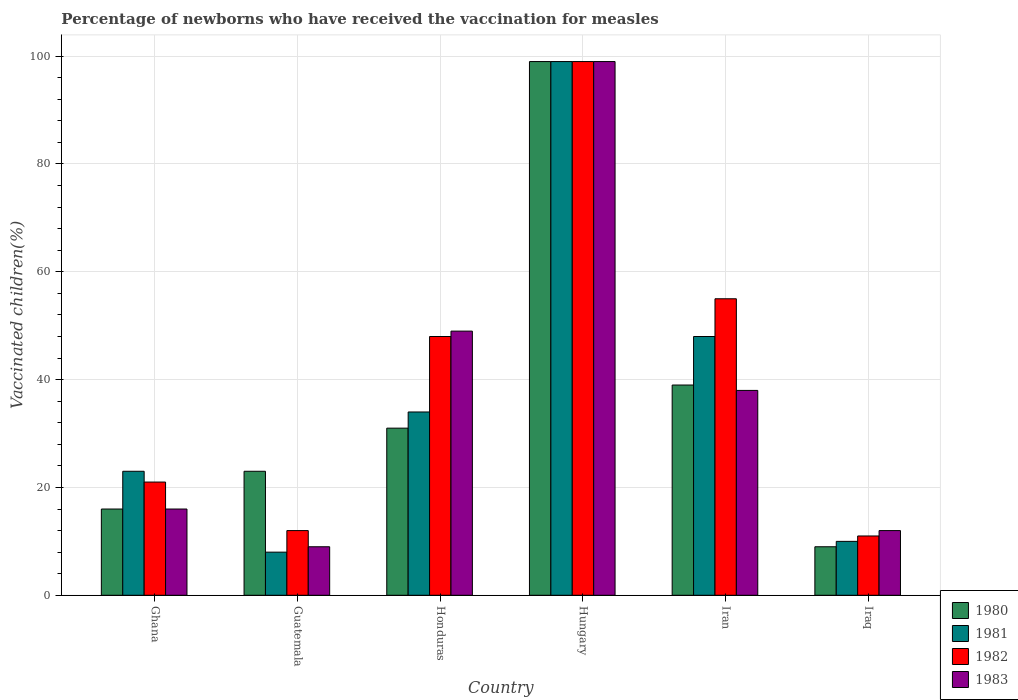How many different coloured bars are there?
Give a very brief answer. 4. Are the number of bars on each tick of the X-axis equal?
Provide a succinct answer. Yes. How many bars are there on the 5th tick from the right?
Make the answer very short. 4. What is the label of the 1st group of bars from the left?
Your answer should be very brief. Ghana. In how many cases, is the number of bars for a given country not equal to the number of legend labels?
Offer a very short reply. 0. Across all countries, what is the maximum percentage of vaccinated children in 1981?
Make the answer very short. 99. In which country was the percentage of vaccinated children in 1980 maximum?
Provide a succinct answer. Hungary. In which country was the percentage of vaccinated children in 1982 minimum?
Keep it short and to the point. Iraq. What is the total percentage of vaccinated children in 1982 in the graph?
Keep it short and to the point. 246. What is the difference between the percentage of vaccinated children in 1981 in Hungary and the percentage of vaccinated children in 1983 in Iran?
Offer a terse response. 61. What is the average percentage of vaccinated children in 1983 per country?
Give a very brief answer. 37.17. What is the ratio of the percentage of vaccinated children in 1980 in Ghana to that in Guatemala?
Keep it short and to the point. 0.7. What is the difference between the highest and the second highest percentage of vaccinated children in 1982?
Your answer should be compact. -51. What is the difference between the highest and the lowest percentage of vaccinated children in 1981?
Provide a succinct answer. 91. Is the sum of the percentage of vaccinated children in 1980 in Guatemala and Honduras greater than the maximum percentage of vaccinated children in 1982 across all countries?
Provide a short and direct response. No. Is it the case that in every country, the sum of the percentage of vaccinated children in 1983 and percentage of vaccinated children in 1980 is greater than the sum of percentage of vaccinated children in 1981 and percentage of vaccinated children in 1982?
Give a very brief answer. No. Are all the bars in the graph horizontal?
Make the answer very short. No. Does the graph contain any zero values?
Your response must be concise. No. Does the graph contain grids?
Offer a very short reply. Yes. How are the legend labels stacked?
Keep it short and to the point. Vertical. What is the title of the graph?
Keep it short and to the point. Percentage of newborns who have received the vaccination for measles. Does "1969" appear as one of the legend labels in the graph?
Offer a terse response. No. What is the label or title of the Y-axis?
Make the answer very short. Vaccinated children(%). What is the Vaccinated children(%) in 1980 in Ghana?
Make the answer very short. 16. What is the Vaccinated children(%) of 1983 in Ghana?
Offer a terse response. 16. What is the Vaccinated children(%) in 1981 in Guatemala?
Ensure brevity in your answer.  8. What is the Vaccinated children(%) in 1983 in Guatemala?
Provide a short and direct response. 9. What is the Vaccinated children(%) of 1980 in Honduras?
Your answer should be very brief. 31. What is the Vaccinated children(%) in 1982 in Honduras?
Offer a terse response. 48. What is the Vaccinated children(%) in 1980 in Hungary?
Ensure brevity in your answer.  99. What is the Vaccinated children(%) in 1981 in Hungary?
Ensure brevity in your answer.  99. What is the Vaccinated children(%) in 1982 in Hungary?
Offer a very short reply. 99. What is the Vaccinated children(%) of 1980 in Iran?
Give a very brief answer. 39. What is the Vaccinated children(%) of 1981 in Iran?
Provide a succinct answer. 48. What is the Vaccinated children(%) of 1980 in Iraq?
Your response must be concise. 9. Across all countries, what is the maximum Vaccinated children(%) of 1980?
Your answer should be compact. 99. Across all countries, what is the maximum Vaccinated children(%) of 1981?
Give a very brief answer. 99. Across all countries, what is the maximum Vaccinated children(%) of 1983?
Make the answer very short. 99. Across all countries, what is the minimum Vaccinated children(%) of 1981?
Make the answer very short. 8. Across all countries, what is the minimum Vaccinated children(%) in 1983?
Offer a very short reply. 9. What is the total Vaccinated children(%) in 1980 in the graph?
Provide a succinct answer. 217. What is the total Vaccinated children(%) in 1981 in the graph?
Your response must be concise. 222. What is the total Vaccinated children(%) in 1982 in the graph?
Ensure brevity in your answer.  246. What is the total Vaccinated children(%) in 1983 in the graph?
Your response must be concise. 223. What is the difference between the Vaccinated children(%) in 1983 in Ghana and that in Guatemala?
Ensure brevity in your answer.  7. What is the difference between the Vaccinated children(%) in 1983 in Ghana and that in Honduras?
Make the answer very short. -33. What is the difference between the Vaccinated children(%) of 1980 in Ghana and that in Hungary?
Keep it short and to the point. -83. What is the difference between the Vaccinated children(%) in 1981 in Ghana and that in Hungary?
Offer a very short reply. -76. What is the difference between the Vaccinated children(%) in 1982 in Ghana and that in Hungary?
Make the answer very short. -78. What is the difference between the Vaccinated children(%) in 1983 in Ghana and that in Hungary?
Provide a short and direct response. -83. What is the difference between the Vaccinated children(%) of 1980 in Ghana and that in Iran?
Your answer should be very brief. -23. What is the difference between the Vaccinated children(%) in 1982 in Ghana and that in Iran?
Provide a short and direct response. -34. What is the difference between the Vaccinated children(%) of 1983 in Ghana and that in Iran?
Offer a terse response. -22. What is the difference between the Vaccinated children(%) in 1981 in Ghana and that in Iraq?
Offer a very short reply. 13. What is the difference between the Vaccinated children(%) of 1982 in Ghana and that in Iraq?
Keep it short and to the point. 10. What is the difference between the Vaccinated children(%) of 1983 in Ghana and that in Iraq?
Offer a terse response. 4. What is the difference between the Vaccinated children(%) of 1982 in Guatemala and that in Honduras?
Your response must be concise. -36. What is the difference between the Vaccinated children(%) of 1980 in Guatemala and that in Hungary?
Offer a very short reply. -76. What is the difference between the Vaccinated children(%) in 1981 in Guatemala and that in Hungary?
Your answer should be very brief. -91. What is the difference between the Vaccinated children(%) of 1982 in Guatemala and that in Hungary?
Your answer should be very brief. -87. What is the difference between the Vaccinated children(%) in 1983 in Guatemala and that in Hungary?
Ensure brevity in your answer.  -90. What is the difference between the Vaccinated children(%) in 1982 in Guatemala and that in Iran?
Your answer should be compact. -43. What is the difference between the Vaccinated children(%) of 1981 in Guatemala and that in Iraq?
Keep it short and to the point. -2. What is the difference between the Vaccinated children(%) in 1983 in Guatemala and that in Iraq?
Offer a very short reply. -3. What is the difference between the Vaccinated children(%) of 1980 in Honduras and that in Hungary?
Give a very brief answer. -68. What is the difference between the Vaccinated children(%) in 1981 in Honduras and that in Hungary?
Give a very brief answer. -65. What is the difference between the Vaccinated children(%) in 1982 in Honduras and that in Hungary?
Your response must be concise. -51. What is the difference between the Vaccinated children(%) of 1983 in Honduras and that in Hungary?
Keep it short and to the point. -50. What is the difference between the Vaccinated children(%) in 1980 in Honduras and that in Iran?
Keep it short and to the point. -8. What is the difference between the Vaccinated children(%) in 1983 in Honduras and that in Iran?
Give a very brief answer. 11. What is the difference between the Vaccinated children(%) of 1980 in Honduras and that in Iraq?
Provide a short and direct response. 22. What is the difference between the Vaccinated children(%) in 1982 in Honduras and that in Iraq?
Keep it short and to the point. 37. What is the difference between the Vaccinated children(%) in 1983 in Honduras and that in Iraq?
Provide a short and direct response. 37. What is the difference between the Vaccinated children(%) of 1981 in Hungary and that in Iran?
Offer a terse response. 51. What is the difference between the Vaccinated children(%) in 1980 in Hungary and that in Iraq?
Provide a short and direct response. 90. What is the difference between the Vaccinated children(%) in 1981 in Hungary and that in Iraq?
Offer a terse response. 89. What is the difference between the Vaccinated children(%) in 1982 in Hungary and that in Iraq?
Your answer should be very brief. 88. What is the difference between the Vaccinated children(%) in 1980 in Iran and that in Iraq?
Give a very brief answer. 30. What is the difference between the Vaccinated children(%) of 1981 in Iran and that in Iraq?
Offer a terse response. 38. What is the difference between the Vaccinated children(%) of 1980 in Ghana and the Vaccinated children(%) of 1981 in Guatemala?
Your answer should be compact. 8. What is the difference between the Vaccinated children(%) of 1981 in Ghana and the Vaccinated children(%) of 1982 in Guatemala?
Give a very brief answer. 11. What is the difference between the Vaccinated children(%) of 1980 in Ghana and the Vaccinated children(%) of 1982 in Honduras?
Make the answer very short. -32. What is the difference between the Vaccinated children(%) in 1980 in Ghana and the Vaccinated children(%) in 1983 in Honduras?
Make the answer very short. -33. What is the difference between the Vaccinated children(%) in 1981 in Ghana and the Vaccinated children(%) in 1982 in Honduras?
Your response must be concise. -25. What is the difference between the Vaccinated children(%) of 1981 in Ghana and the Vaccinated children(%) of 1983 in Honduras?
Your answer should be very brief. -26. What is the difference between the Vaccinated children(%) in 1982 in Ghana and the Vaccinated children(%) in 1983 in Honduras?
Make the answer very short. -28. What is the difference between the Vaccinated children(%) in 1980 in Ghana and the Vaccinated children(%) in 1981 in Hungary?
Give a very brief answer. -83. What is the difference between the Vaccinated children(%) in 1980 in Ghana and the Vaccinated children(%) in 1982 in Hungary?
Offer a very short reply. -83. What is the difference between the Vaccinated children(%) in 1980 in Ghana and the Vaccinated children(%) in 1983 in Hungary?
Your answer should be very brief. -83. What is the difference between the Vaccinated children(%) of 1981 in Ghana and the Vaccinated children(%) of 1982 in Hungary?
Ensure brevity in your answer.  -76. What is the difference between the Vaccinated children(%) in 1981 in Ghana and the Vaccinated children(%) in 1983 in Hungary?
Offer a terse response. -76. What is the difference between the Vaccinated children(%) in 1982 in Ghana and the Vaccinated children(%) in 1983 in Hungary?
Give a very brief answer. -78. What is the difference between the Vaccinated children(%) of 1980 in Ghana and the Vaccinated children(%) of 1981 in Iran?
Your response must be concise. -32. What is the difference between the Vaccinated children(%) in 1980 in Ghana and the Vaccinated children(%) in 1982 in Iran?
Your response must be concise. -39. What is the difference between the Vaccinated children(%) of 1980 in Ghana and the Vaccinated children(%) of 1983 in Iran?
Give a very brief answer. -22. What is the difference between the Vaccinated children(%) of 1981 in Ghana and the Vaccinated children(%) of 1982 in Iran?
Ensure brevity in your answer.  -32. What is the difference between the Vaccinated children(%) in 1982 in Ghana and the Vaccinated children(%) in 1983 in Iran?
Offer a very short reply. -17. What is the difference between the Vaccinated children(%) in 1980 in Ghana and the Vaccinated children(%) in 1981 in Iraq?
Provide a succinct answer. 6. What is the difference between the Vaccinated children(%) of 1981 in Ghana and the Vaccinated children(%) of 1982 in Iraq?
Provide a succinct answer. 12. What is the difference between the Vaccinated children(%) in 1982 in Ghana and the Vaccinated children(%) in 1983 in Iraq?
Offer a terse response. 9. What is the difference between the Vaccinated children(%) of 1980 in Guatemala and the Vaccinated children(%) of 1981 in Honduras?
Make the answer very short. -11. What is the difference between the Vaccinated children(%) of 1980 in Guatemala and the Vaccinated children(%) of 1982 in Honduras?
Give a very brief answer. -25. What is the difference between the Vaccinated children(%) of 1981 in Guatemala and the Vaccinated children(%) of 1982 in Honduras?
Offer a very short reply. -40. What is the difference between the Vaccinated children(%) in 1981 in Guatemala and the Vaccinated children(%) in 1983 in Honduras?
Provide a short and direct response. -41. What is the difference between the Vaccinated children(%) of 1982 in Guatemala and the Vaccinated children(%) of 1983 in Honduras?
Keep it short and to the point. -37. What is the difference between the Vaccinated children(%) in 1980 in Guatemala and the Vaccinated children(%) in 1981 in Hungary?
Ensure brevity in your answer.  -76. What is the difference between the Vaccinated children(%) of 1980 in Guatemala and the Vaccinated children(%) of 1982 in Hungary?
Make the answer very short. -76. What is the difference between the Vaccinated children(%) of 1980 in Guatemala and the Vaccinated children(%) of 1983 in Hungary?
Provide a succinct answer. -76. What is the difference between the Vaccinated children(%) of 1981 in Guatemala and the Vaccinated children(%) of 1982 in Hungary?
Keep it short and to the point. -91. What is the difference between the Vaccinated children(%) of 1981 in Guatemala and the Vaccinated children(%) of 1983 in Hungary?
Ensure brevity in your answer.  -91. What is the difference between the Vaccinated children(%) in 1982 in Guatemala and the Vaccinated children(%) in 1983 in Hungary?
Ensure brevity in your answer.  -87. What is the difference between the Vaccinated children(%) in 1980 in Guatemala and the Vaccinated children(%) in 1981 in Iran?
Offer a very short reply. -25. What is the difference between the Vaccinated children(%) in 1980 in Guatemala and the Vaccinated children(%) in 1982 in Iran?
Offer a very short reply. -32. What is the difference between the Vaccinated children(%) in 1980 in Guatemala and the Vaccinated children(%) in 1983 in Iran?
Your answer should be compact. -15. What is the difference between the Vaccinated children(%) of 1981 in Guatemala and the Vaccinated children(%) of 1982 in Iran?
Make the answer very short. -47. What is the difference between the Vaccinated children(%) in 1981 in Guatemala and the Vaccinated children(%) in 1983 in Iran?
Ensure brevity in your answer.  -30. What is the difference between the Vaccinated children(%) of 1982 in Guatemala and the Vaccinated children(%) of 1983 in Iran?
Your response must be concise. -26. What is the difference between the Vaccinated children(%) in 1980 in Guatemala and the Vaccinated children(%) in 1981 in Iraq?
Your response must be concise. 13. What is the difference between the Vaccinated children(%) in 1980 in Guatemala and the Vaccinated children(%) in 1982 in Iraq?
Provide a short and direct response. 12. What is the difference between the Vaccinated children(%) in 1981 in Guatemala and the Vaccinated children(%) in 1982 in Iraq?
Your response must be concise. -3. What is the difference between the Vaccinated children(%) of 1981 in Guatemala and the Vaccinated children(%) of 1983 in Iraq?
Your answer should be very brief. -4. What is the difference between the Vaccinated children(%) in 1982 in Guatemala and the Vaccinated children(%) in 1983 in Iraq?
Your answer should be very brief. 0. What is the difference between the Vaccinated children(%) in 1980 in Honduras and the Vaccinated children(%) in 1981 in Hungary?
Offer a terse response. -68. What is the difference between the Vaccinated children(%) in 1980 in Honduras and the Vaccinated children(%) in 1982 in Hungary?
Your answer should be compact. -68. What is the difference between the Vaccinated children(%) in 1980 in Honduras and the Vaccinated children(%) in 1983 in Hungary?
Ensure brevity in your answer.  -68. What is the difference between the Vaccinated children(%) in 1981 in Honduras and the Vaccinated children(%) in 1982 in Hungary?
Your response must be concise. -65. What is the difference between the Vaccinated children(%) in 1981 in Honduras and the Vaccinated children(%) in 1983 in Hungary?
Give a very brief answer. -65. What is the difference between the Vaccinated children(%) in 1982 in Honduras and the Vaccinated children(%) in 1983 in Hungary?
Offer a very short reply. -51. What is the difference between the Vaccinated children(%) of 1980 in Honduras and the Vaccinated children(%) of 1982 in Iran?
Provide a short and direct response. -24. What is the difference between the Vaccinated children(%) in 1981 in Honduras and the Vaccinated children(%) in 1982 in Iran?
Offer a very short reply. -21. What is the difference between the Vaccinated children(%) in 1980 in Honduras and the Vaccinated children(%) in 1983 in Iraq?
Your answer should be compact. 19. What is the difference between the Vaccinated children(%) of 1981 in Honduras and the Vaccinated children(%) of 1983 in Iraq?
Make the answer very short. 22. What is the difference between the Vaccinated children(%) of 1980 in Hungary and the Vaccinated children(%) of 1981 in Iran?
Your answer should be very brief. 51. What is the difference between the Vaccinated children(%) of 1980 in Hungary and the Vaccinated children(%) of 1983 in Iran?
Keep it short and to the point. 61. What is the difference between the Vaccinated children(%) of 1981 in Hungary and the Vaccinated children(%) of 1982 in Iran?
Keep it short and to the point. 44. What is the difference between the Vaccinated children(%) in 1981 in Hungary and the Vaccinated children(%) in 1983 in Iran?
Keep it short and to the point. 61. What is the difference between the Vaccinated children(%) of 1980 in Hungary and the Vaccinated children(%) of 1981 in Iraq?
Keep it short and to the point. 89. What is the difference between the Vaccinated children(%) of 1980 in Hungary and the Vaccinated children(%) of 1982 in Iraq?
Offer a very short reply. 88. What is the difference between the Vaccinated children(%) in 1980 in Hungary and the Vaccinated children(%) in 1983 in Iraq?
Make the answer very short. 87. What is the difference between the Vaccinated children(%) of 1981 in Hungary and the Vaccinated children(%) of 1982 in Iraq?
Give a very brief answer. 88. What is the difference between the Vaccinated children(%) in 1981 in Hungary and the Vaccinated children(%) in 1983 in Iraq?
Offer a terse response. 87. What is the difference between the Vaccinated children(%) of 1982 in Hungary and the Vaccinated children(%) of 1983 in Iraq?
Give a very brief answer. 87. What is the difference between the Vaccinated children(%) of 1980 in Iran and the Vaccinated children(%) of 1981 in Iraq?
Offer a terse response. 29. What is the difference between the Vaccinated children(%) of 1981 in Iran and the Vaccinated children(%) of 1982 in Iraq?
Your response must be concise. 37. What is the difference between the Vaccinated children(%) in 1981 in Iran and the Vaccinated children(%) in 1983 in Iraq?
Your answer should be compact. 36. What is the average Vaccinated children(%) of 1980 per country?
Offer a very short reply. 36.17. What is the average Vaccinated children(%) in 1983 per country?
Ensure brevity in your answer.  37.17. What is the difference between the Vaccinated children(%) of 1980 and Vaccinated children(%) of 1981 in Ghana?
Give a very brief answer. -7. What is the difference between the Vaccinated children(%) in 1981 and Vaccinated children(%) in 1983 in Ghana?
Provide a short and direct response. 7. What is the difference between the Vaccinated children(%) in 1982 and Vaccinated children(%) in 1983 in Ghana?
Offer a very short reply. 5. What is the difference between the Vaccinated children(%) of 1980 and Vaccinated children(%) of 1981 in Guatemala?
Keep it short and to the point. 15. What is the difference between the Vaccinated children(%) of 1980 and Vaccinated children(%) of 1982 in Guatemala?
Make the answer very short. 11. What is the difference between the Vaccinated children(%) of 1980 and Vaccinated children(%) of 1983 in Guatemala?
Offer a terse response. 14. What is the difference between the Vaccinated children(%) in 1981 and Vaccinated children(%) in 1982 in Guatemala?
Make the answer very short. -4. What is the difference between the Vaccinated children(%) in 1981 and Vaccinated children(%) in 1983 in Guatemala?
Give a very brief answer. -1. What is the difference between the Vaccinated children(%) of 1981 and Vaccinated children(%) of 1982 in Honduras?
Your answer should be very brief. -14. What is the difference between the Vaccinated children(%) of 1981 and Vaccinated children(%) of 1983 in Honduras?
Provide a short and direct response. -15. What is the difference between the Vaccinated children(%) of 1982 and Vaccinated children(%) of 1983 in Honduras?
Give a very brief answer. -1. What is the difference between the Vaccinated children(%) in 1980 and Vaccinated children(%) in 1981 in Hungary?
Provide a succinct answer. 0. What is the difference between the Vaccinated children(%) in 1980 and Vaccinated children(%) in 1982 in Hungary?
Your answer should be very brief. 0. What is the difference between the Vaccinated children(%) of 1980 and Vaccinated children(%) of 1983 in Hungary?
Your response must be concise. 0. What is the difference between the Vaccinated children(%) of 1981 and Vaccinated children(%) of 1982 in Hungary?
Offer a terse response. 0. What is the difference between the Vaccinated children(%) in 1981 and Vaccinated children(%) in 1983 in Hungary?
Keep it short and to the point. 0. What is the difference between the Vaccinated children(%) in 1982 and Vaccinated children(%) in 1983 in Hungary?
Provide a short and direct response. 0. What is the difference between the Vaccinated children(%) of 1980 and Vaccinated children(%) of 1981 in Iran?
Provide a succinct answer. -9. What is the difference between the Vaccinated children(%) in 1982 and Vaccinated children(%) in 1983 in Iran?
Offer a very short reply. 17. What is the difference between the Vaccinated children(%) of 1980 and Vaccinated children(%) of 1981 in Iraq?
Give a very brief answer. -1. What is the difference between the Vaccinated children(%) in 1980 and Vaccinated children(%) in 1983 in Iraq?
Keep it short and to the point. -3. What is the difference between the Vaccinated children(%) in 1982 and Vaccinated children(%) in 1983 in Iraq?
Your response must be concise. -1. What is the ratio of the Vaccinated children(%) in 1980 in Ghana to that in Guatemala?
Give a very brief answer. 0.7. What is the ratio of the Vaccinated children(%) of 1981 in Ghana to that in Guatemala?
Offer a terse response. 2.88. What is the ratio of the Vaccinated children(%) of 1983 in Ghana to that in Guatemala?
Your response must be concise. 1.78. What is the ratio of the Vaccinated children(%) in 1980 in Ghana to that in Honduras?
Your answer should be compact. 0.52. What is the ratio of the Vaccinated children(%) of 1981 in Ghana to that in Honduras?
Offer a very short reply. 0.68. What is the ratio of the Vaccinated children(%) of 1982 in Ghana to that in Honduras?
Your answer should be compact. 0.44. What is the ratio of the Vaccinated children(%) in 1983 in Ghana to that in Honduras?
Provide a short and direct response. 0.33. What is the ratio of the Vaccinated children(%) in 1980 in Ghana to that in Hungary?
Your answer should be very brief. 0.16. What is the ratio of the Vaccinated children(%) of 1981 in Ghana to that in Hungary?
Keep it short and to the point. 0.23. What is the ratio of the Vaccinated children(%) of 1982 in Ghana to that in Hungary?
Your response must be concise. 0.21. What is the ratio of the Vaccinated children(%) of 1983 in Ghana to that in Hungary?
Provide a short and direct response. 0.16. What is the ratio of the Vaccinated children(%) of 1980 in Ghana to that in Iran?
Make the answer very short. 0.41. What is the ratio of the Vaccinated children(%) in 1981 in Ghana to that in Iran?
Provide a succinct answer. 0.48. What is the ratio of the Vaccinated children(%) of 1982 in Ghana to that in Iran?
Provide a short and direct response. 0.38. What is the ratio of the Vaccinated children(%) in 1983 in Ghana to that in Iran?
Ensure brevity in your answer.  0.42. What is the ratio of the Vaccinated children(%) in 1980 in Ghana to that in Iraq?
Your answer should be compact. 1.78. What is the ratio of the Vaccinated children(%) of 1981 in Ghana to that in Iraq?
Provide a short and direct response. 2.3. What is the ratio of the Vaccinated children(%) in 1982 in Ghana to that in Iraq?
Provide a succinct answer. 1.91. What is the ratio of the Vaccinated children(%) of 1983 in Ghana to that in Iraq?
Provide a short and direct response. 1.33. What is the ratio of the Vaccinated children(%) of 1980 in Guatemala to that in Honduras?
Give a very brief answer. 0.74. What is the ratio of the Vaccinated children(%) of 1981 in Guatemala to that in Honduras?
Provide a short and direct response. 0.24. What is the ratio of the Vaccinated children(%) in 1982 in Guatemala to that in Honduras?
Provide a succinct answer. 0.25. What is the ratio of the Vaccinated children(%) in 1983 in Guatemala to that in Honduras?
Give a very brief answer. 0.18. What is the ratio of the Vaccinated children(%) in 1980 in Guatemala to that in Hungary?
Make the answer very short. 0.23. What is the ratio of the Vaccinated children(%) in 1981 in Guatemala to that in Hungary?
Provide a succinct answer. 0.08. What is the ratio of the Vaccinated children(%) of 1982 in Guatemala to that in Hungary?
Provide a short and direct response. 0.12. What is the ratio of the Vaccinated children(%) in 1983 in Guatemala to that in Hungary?
Offer a terse response. 0.09. What is the ratio of the Vaccinated children(%) in 1980 in Guatemala to that in Iran?
Make the answer very short. 0.59. What is the ratio of the Vaccinated children(%) in 1982 in Guatemala to that in Iran?
Keep it short and to the point. 0.22. What is the ratio of the Vaccinated children(%) of 1983 in Guatemala to that in Iran?
Keep it short and to the point. 0.24. What is the ratio of the Vaccinated children(%) of 1980 in Guatemala to that in Iraq?
Provide a short and direct response. 2.56. What is the ratio of the Vaccinated children(%) in 1980 in Honduras to that in Hungary?
Your answer should be very brief. 0.31. What is the ratio of the Vaccinated children(%) of 1981 in Honduras to that in Hungary?
Provide a short and direct response. 0.34. What is the ratio of the Vaccinated children(%) in 1982 in Honduras to that in Hungary?
Keep it short and to the point. 0.48. What is the ratio of the Vaccinated children(%) of 1983 in Honduras to that in Hungary?
Make the answer very short. 0.49. What is the ratio of the Vaccinated children(%) of 1980 in Honduras to that in Iran?
Offer a very short reply. 0.79. What is the ratio of the Vaccinated children(%) of 1981 in Honduras to that in Iran?
Provide a succinct answer. 0.71. What is the ratio of the Vaccinated children(%) of 1982 in Honduras to that in Iran?
Provide a succinct answer. 0.87. What is the ratio of the Vaccinated children(%) of 1983 in Honduras to that in Iran?
Give a very brief answer. 1.29. What is the ratio of the Vaccinated children(%) in 1980 in Honduras to that in Iraq?
Your answer should be very brief. 3.44. What is the ratio of the Vaccinated children(%) of 1982 in Honduras to that in Iraq?
Offer a very short reply. 4.36. What is the ratio of the Vaccinated children(%) of 1983 in Honduras to that in Iraq?
Keep it short and to the point. 4.08. What is the ratio of the Vaccinated children(%) in 1980 in Hungary to that in Iran?
Ensure brevity in your answer.  2.54. What is the ratio of the Vaccinated children(%) of 1981 in Hungary to that in Iran?
Keep it short and to the point. 2.06. What is the ratio of the Vaccinated children(%) of 1983 in Hungary to that in Iran?
Offer a very short reply. 2.61. What is the ratio of the Vaccinated children(%) of 1980 in Hungary to that in Iraq?
Ensure brevity in your answer.  11. What is the ratio of the Vaccinated children(%) in 1981 in Hungary to that in Iraq?
Keep it short and to the point. 9.9. What is the ratio of the Vaccinated children(%) in 1982 in Hungary to that in Iraq?
Provide a succinct answer. 9. What is the ratio of the Vaccinated children(%) of 1983 in Hungary to that in Iraq?
Offer a very short reply. 8.25. What is the ratio of the Vaccinated children(%) in 1980 in Iran to that in Iraq?
Provide a succinct answer. 4.33. What is the ratio of the Vaccinated children(%) of 1982 in Iran to that in Iraq?
Keep it short and to the point. 5. What is the ratio of the Vaccinated children(%) of 1983 in Iran to that in Iraq?
Give a very brief answer. 3.17. What is the difference between the highest and the second highest Vaccinated children(%) in 1980?
Your answer should be very brief. 60. What is the difference between the highest and the second highest Vaccinated children(%) of 1981?
Give a very brief answer. 51. What is the difference between the highest and the lowest Vaccinated children(%) in 1981?
Ensure brevity in your answer.  91. What is the difference between the highest and the lowest Vaccinated children(%) in 1982?
Offer a very short reply. 88. What is the difference between the highest and the lowest Vaccinated children(%) of 1983?
Give a very brief answer. 90. 